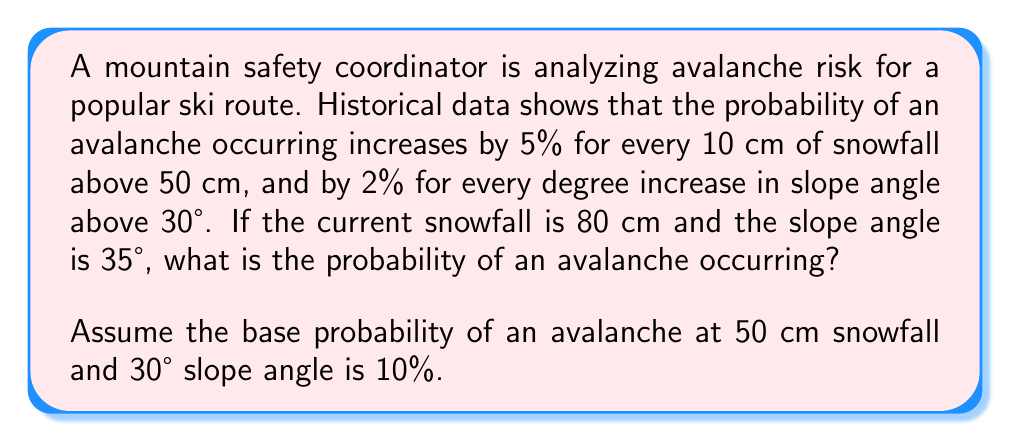Help me with this question. Let's break this down step-by-step:

1) First, calculate the increase in probability due to snowfall:
   - Snowfall above baseline: $80 \text{ cm} - 50 \text{ cm} = 30 \text{ cm}$
   - Increase per 10 cm: $5\%$
   - Total increase: $30 \text{ cm} \div 10 \text{ cm} \times 5\% = 15\%$

2) Next, calculate the increase in probability due to slope angle:
   - Slope angle above baseline: $35° - 30° = 5°$
   - Increase per degree: $2\%$
   - Total increase: $5° \times 2\% = 10\%$

3) Sum up all probability increases:
   - Base probability: $10\%$
   - Increase due to snowfall: $15\%$
   - Increase due to slope angle: $10\%$
   - Total probability: $10\% + 15\% + 10\% = 35\%$

4) Convert percentage to decimal:
   $35\% = 0.35$

Therefore, the probability of an avalanche occurring under these conditions is 0.35 or 35%.
Answer: 0.35 